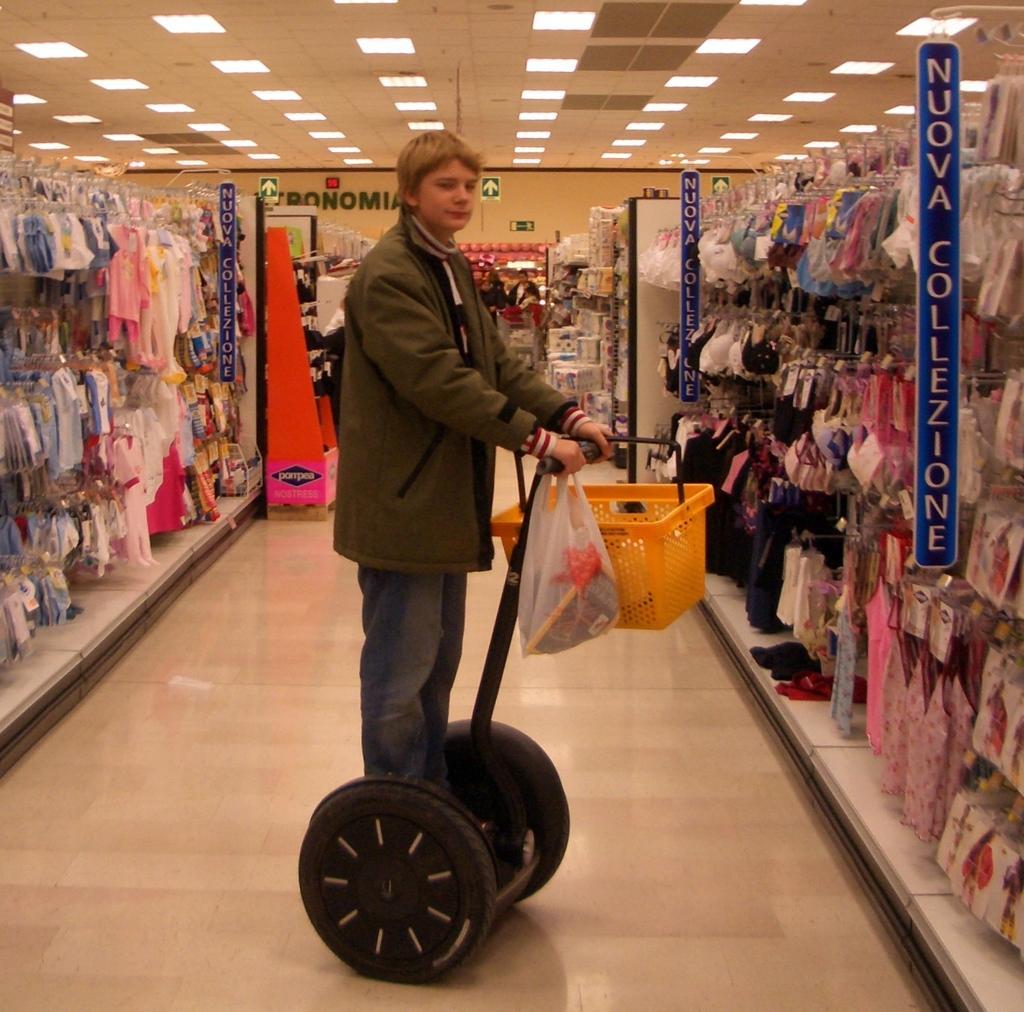Can you describe this image briefly? In the foreground I can see a person is standing on a two wheel vehicle and holding a basket in hand. In the background I can see clothes are hanged, wall and a rooftop on which lights are mounted. This image is taken may be in a shop. 